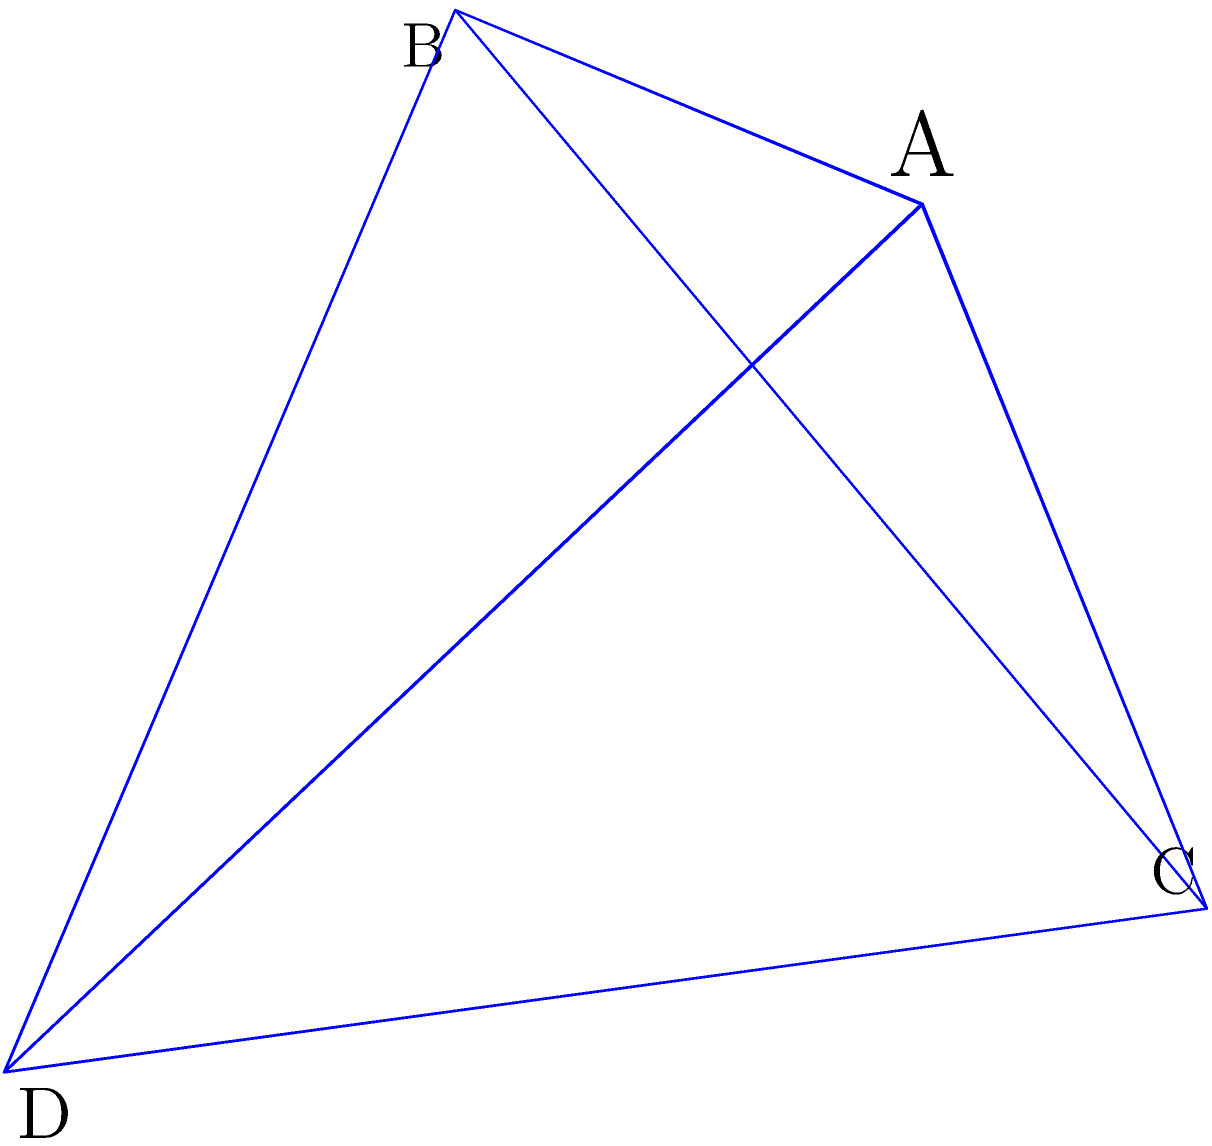A quantum encryption key is represented as a tetrahedron ABCD. How many elements are in the symmetry group of this 3D object, and what is the group isomorphic to? To solve this problem, let's follow these steps:

1) First, we need to identify all the symmetries of a tetrahedron:
   - Identity transformation (1)
   - Rotations by 120° about each of the 4 axes through a vertex and the center of the opposite face (4 * 2 = 8)
   - Rotations by 180° about each of the 3 axes through the midpoints of opposite edges (3)
   - Reflections across 6 planes, each containing an edge and bisecting the opposite edge (6)

2) Counting these symmetries:
   1 + 8 + 3 + 6 = 24 total symmetries

3) The group formed by these symmetries is known as the tetrahedral group, which is isomorphic to $A_4$, the alternating group on 4 elements.

4) To verify this:
   - $A_4$ is the group of even permutations on 4 elements
   - It has order 4!/2 = 24, matching our count of symmetries
   - The structure of rotations and reflections in the tetrahedral group corresponds to the even permutations in $A_4$

5) In the context of cryptography, understanding this symmetry group could be crucial for analyzing the strength and properties of the encryption key, especially in quantum cryptographic protocols where geometric representations might be used.
Answer: 24 elements; isomorphic to $A_4$ 